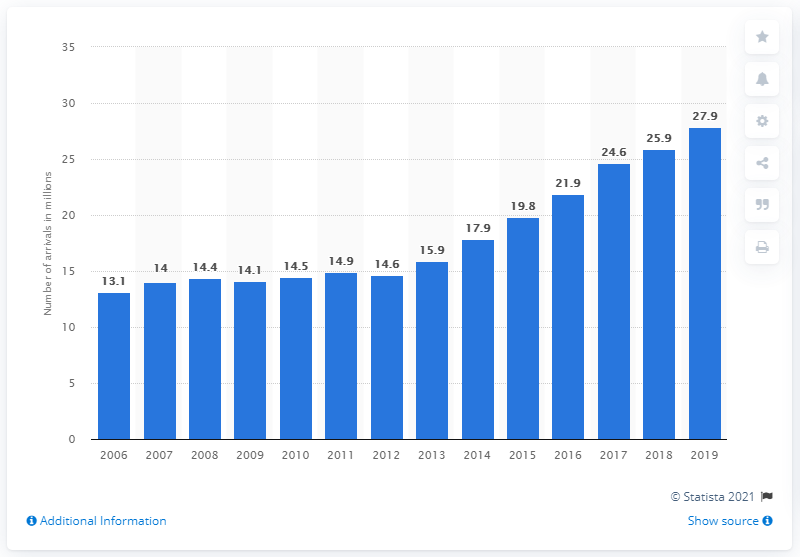Point out several critical features in this image. In 2019, a total of 27,900 arrivals were recorded at accommodation establishments in Portugal. In 2019, there was a 27.9% increase in the number of extra tourists who visited Portugal compared to the number of tourists who visited in 2014. 